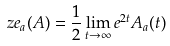<formula> <loc_0><loc_0><loc_500><loc_500>\ z e _ { a } ( A ) = \frac { 1 } { 2 } \lim _ { t \to \infty } e ^ { 2 t } A _ { a } ( t )</formula> 